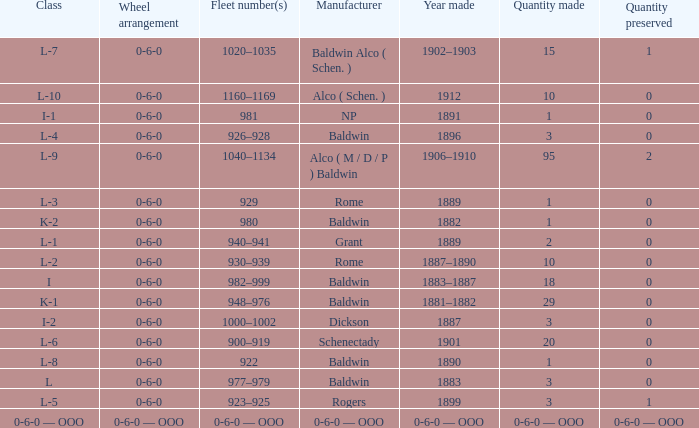Parse the table in full. {'header': ['Class', 'Wheel arrangement', 'Fleet number(s)', 'Manufacturer', 'Year made', 'Quantity made', 'Quantity preserved'], 'rows': [['L-7', '0-6-0', '1020–1035', 'Baldwin Alco ( Schen. )', '1902–1903', '15', '1'], ['L-10', '0-6-0', '1160–1169', 'Alco ( Schen. )', '1912', '10', '0'], ['I-1', '0-6-0', '981', 'NP', '1891', '1', '0'], ['L-4', '0-6-0', '926–928', 'Baldwin', '1896', '3', '0'], ['L-9', '0-6-0', '1040–1134', 'Alco ( M / D / P ) Baldwin', '1906–1910', '95', '2'], ['L-3', '0-6-0', '929', 'Rome', '1889', '1', '0'], ['K-2', '0-6-0', '980', 'Baldwin', '1882', '1', '0'], ['L-1', '0-6-0', '940–941', 'Grant', '1889', '2', '0'], ['L-2', '0-6-0', '930–939', 'Rome', '1887–1890', '10', '0'], ['I', '0-6-0', '982–999', 'Baldwin', '1883–1887', '18', '0'], ['K-1', '0-6-0', '948–976', 'Baldwin', '1881–1882', '29', '0'], ['I-2', '0-6-0', '1000–1002', 'Dickson', '1887', '3', '0'], ['L-6', '0-6-0', '900–919', 'Schenectady', '1901', '20', '0'], ['L-8', '0-6-0', '922', 'Baldwin', '1890', '1', '0'], ['L', '0-6-0', '977–979', 'Baldwin', '1883', '3', '0'], ['L-5', '0-6-0', '923–925', 'Rogers', '1899', '3', '1'], ['0-6-0 — OOO', '0-6-0 — OOO', '0-6-0 — OOO', '0-6-0 — OOO', '0-6-0 — OOO', '0-6-0 — OOO', '0-6-0 — OOO']]} Which Class has a Quantity made of 29? K-1. 